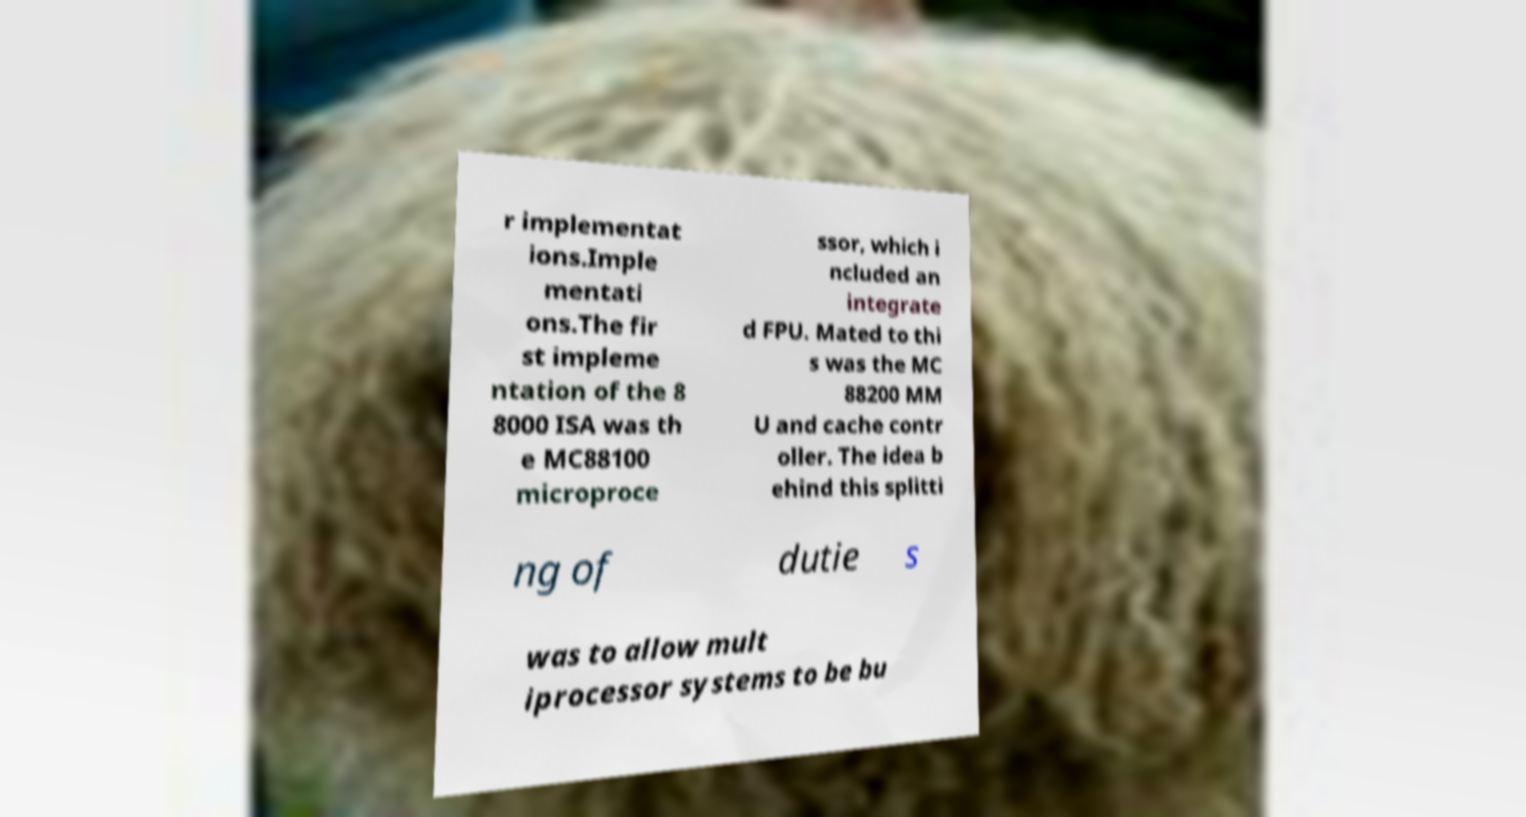I need the written content from this picture converted into text. Can you do that? r implementat ions.Imple mentati ons.The fir st impleme ntation of the 8 8000 ISA was th e MC88100 microproce ssor, which i ncluded an integrate d FPU. Mated to thi s was the MC 88200 MM U and cache contr oller. The idea b ehind this splitti ng of dutie s was to allow mult iprocessor systems to be bu 